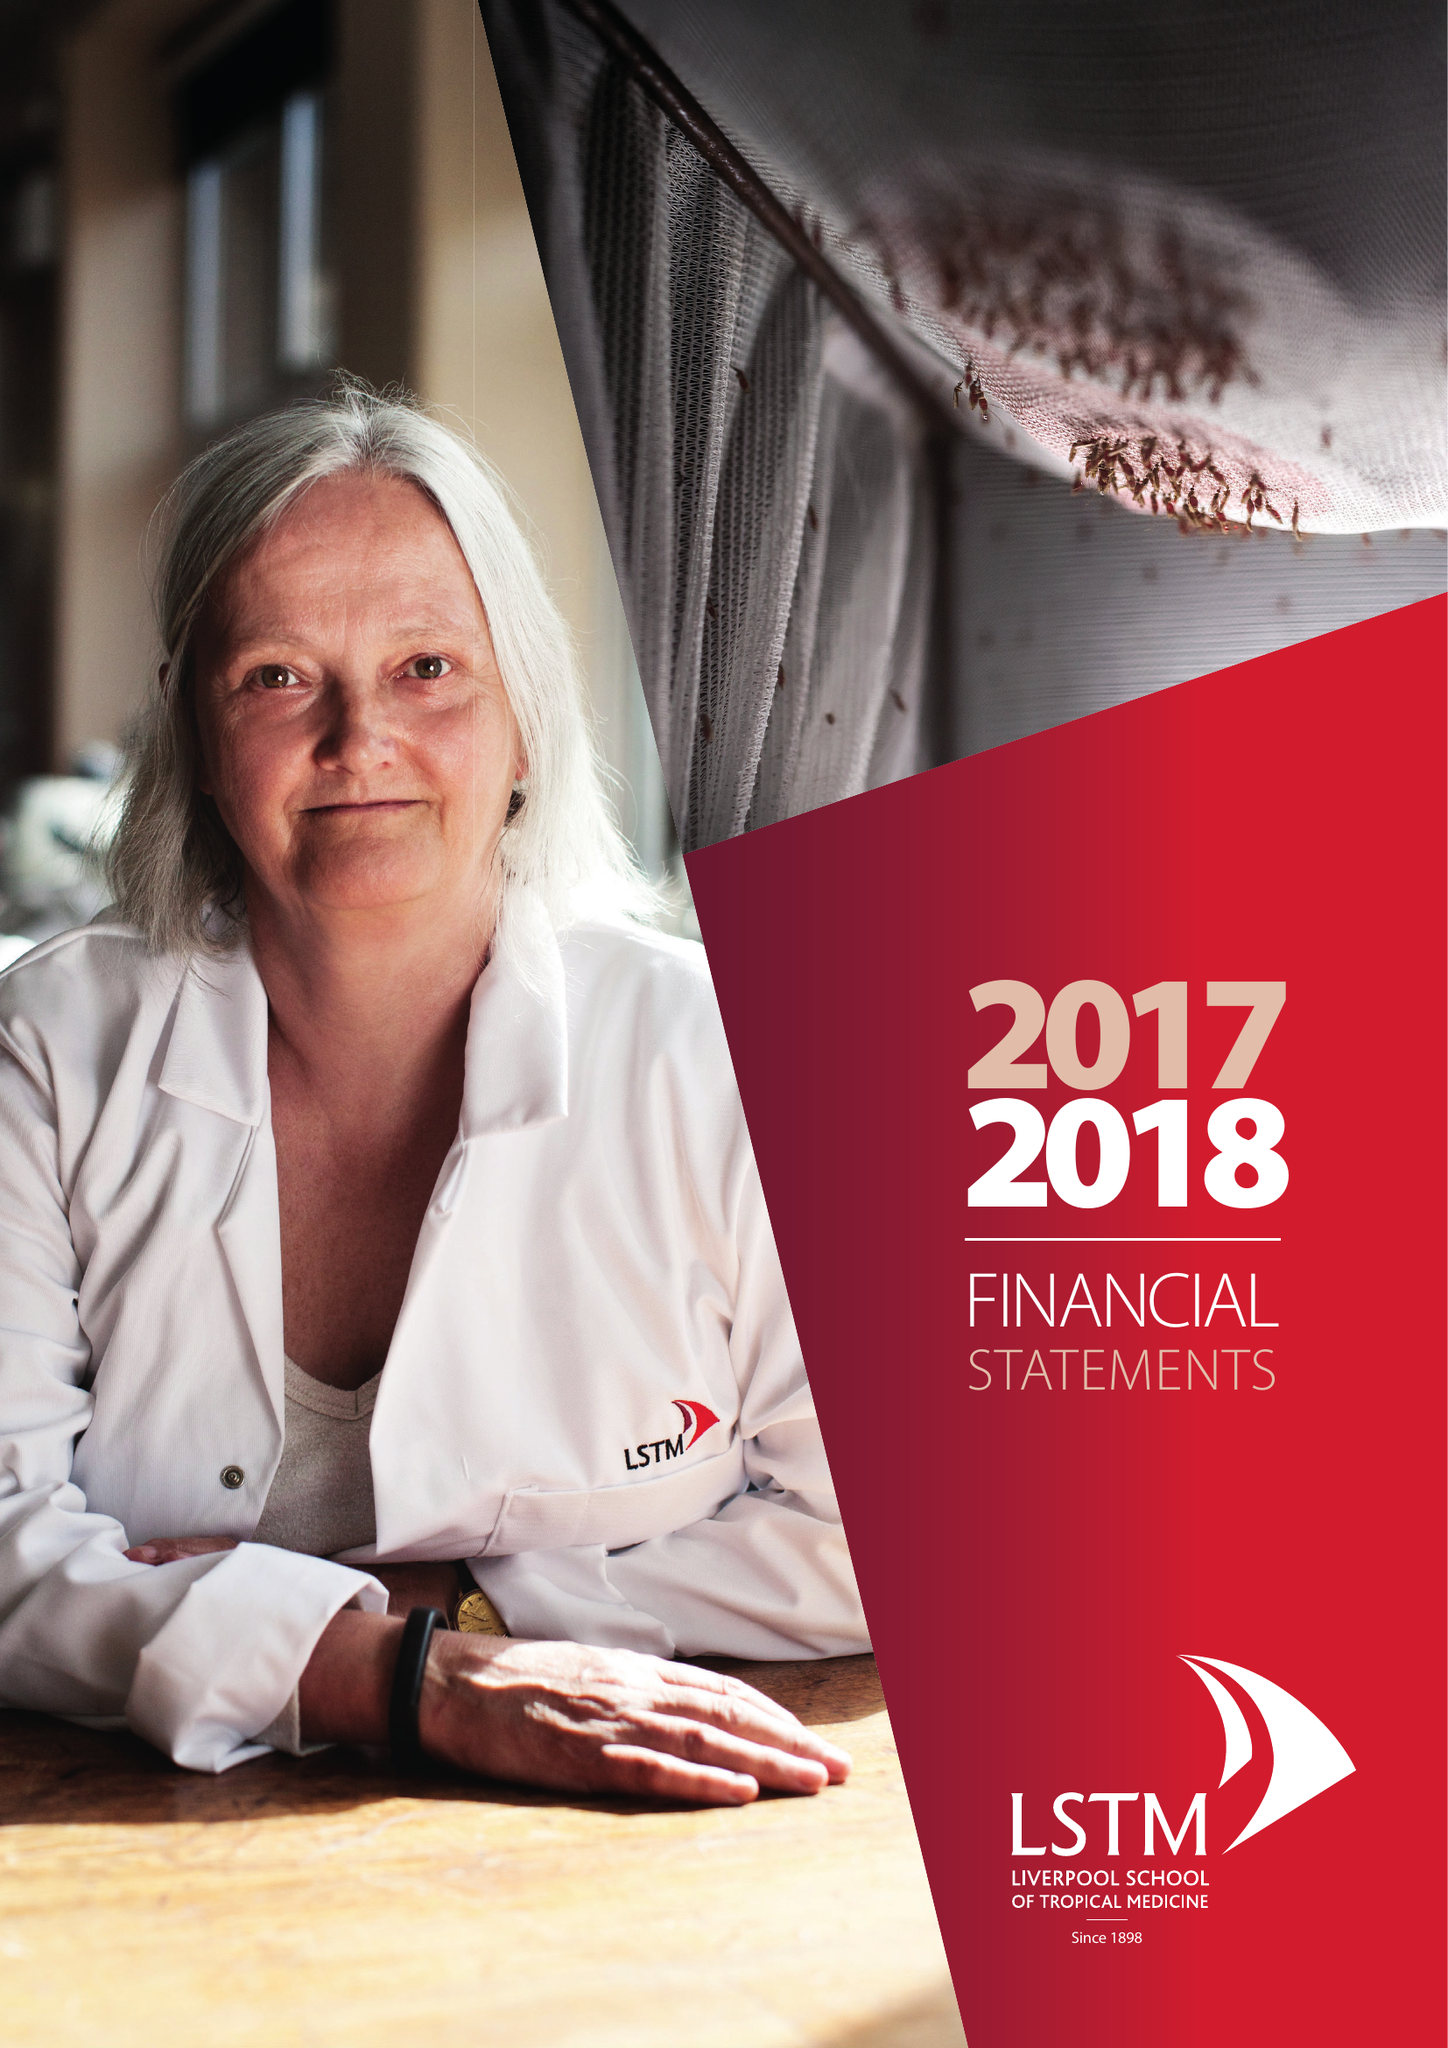What is the value for the spending_annually_in_british_pounds?
Answer the question using a single word or phrase. 227449000.00 